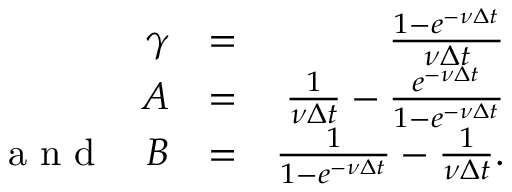Convert formula to latex. <formula><loc_0><loc_0><loc_500><loc_500>\begin{array} { r l r } { \gamma } & { = } & { \frac { 1 - e ^ { - \nu \Delta t } } { \nu \Delta t } } \\ { A } & { = } & { \frac { 1 } { \nu \Delta t } - \frac { e ^ { - \nu \Delta t } } { 1 - e ^ { - \nu \Delta t } } } \\ { a n d \quad B } & { = } & { \frac { 1 } { 1 - e ^ { - \nu \Delta t } } - \frac { 1 } { \nu \Delta t } . } \end{array}</formula> 